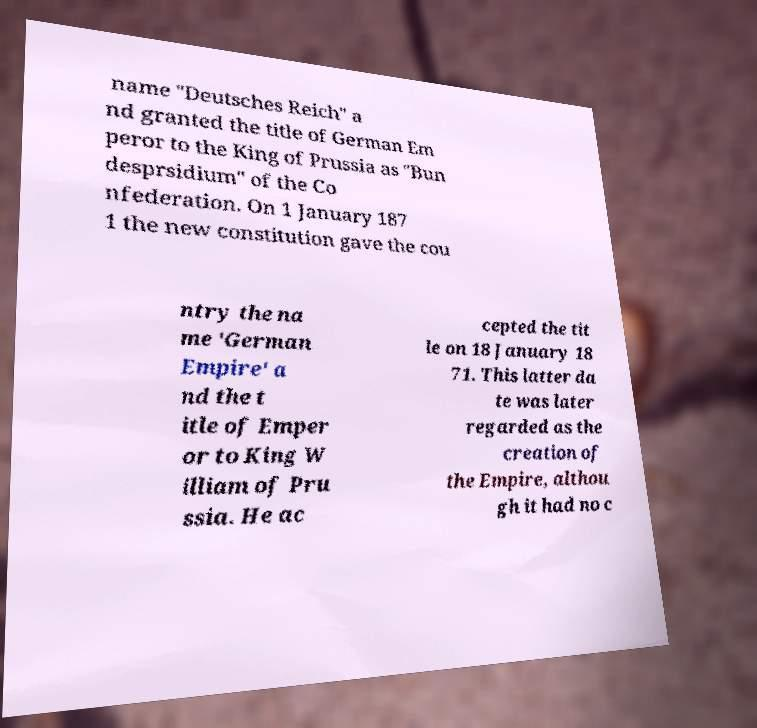Can you accurately transcribe the text from the provided image for me? name "Deutsches Reich" a nd granted the title of German Em peror to the King of Prussia as "Bun desprsidium" of the Co nfederation. On 1 January 187 1 the new constitution gave the cou ntry the na me 'German Empire' a nd the t itle of Emper or to King W illiam of Pru ssia. He ac cepted the tit le on 18 January 18 71. This latter da te was later regarded as the creation of the Empire, althou gh it had no c 